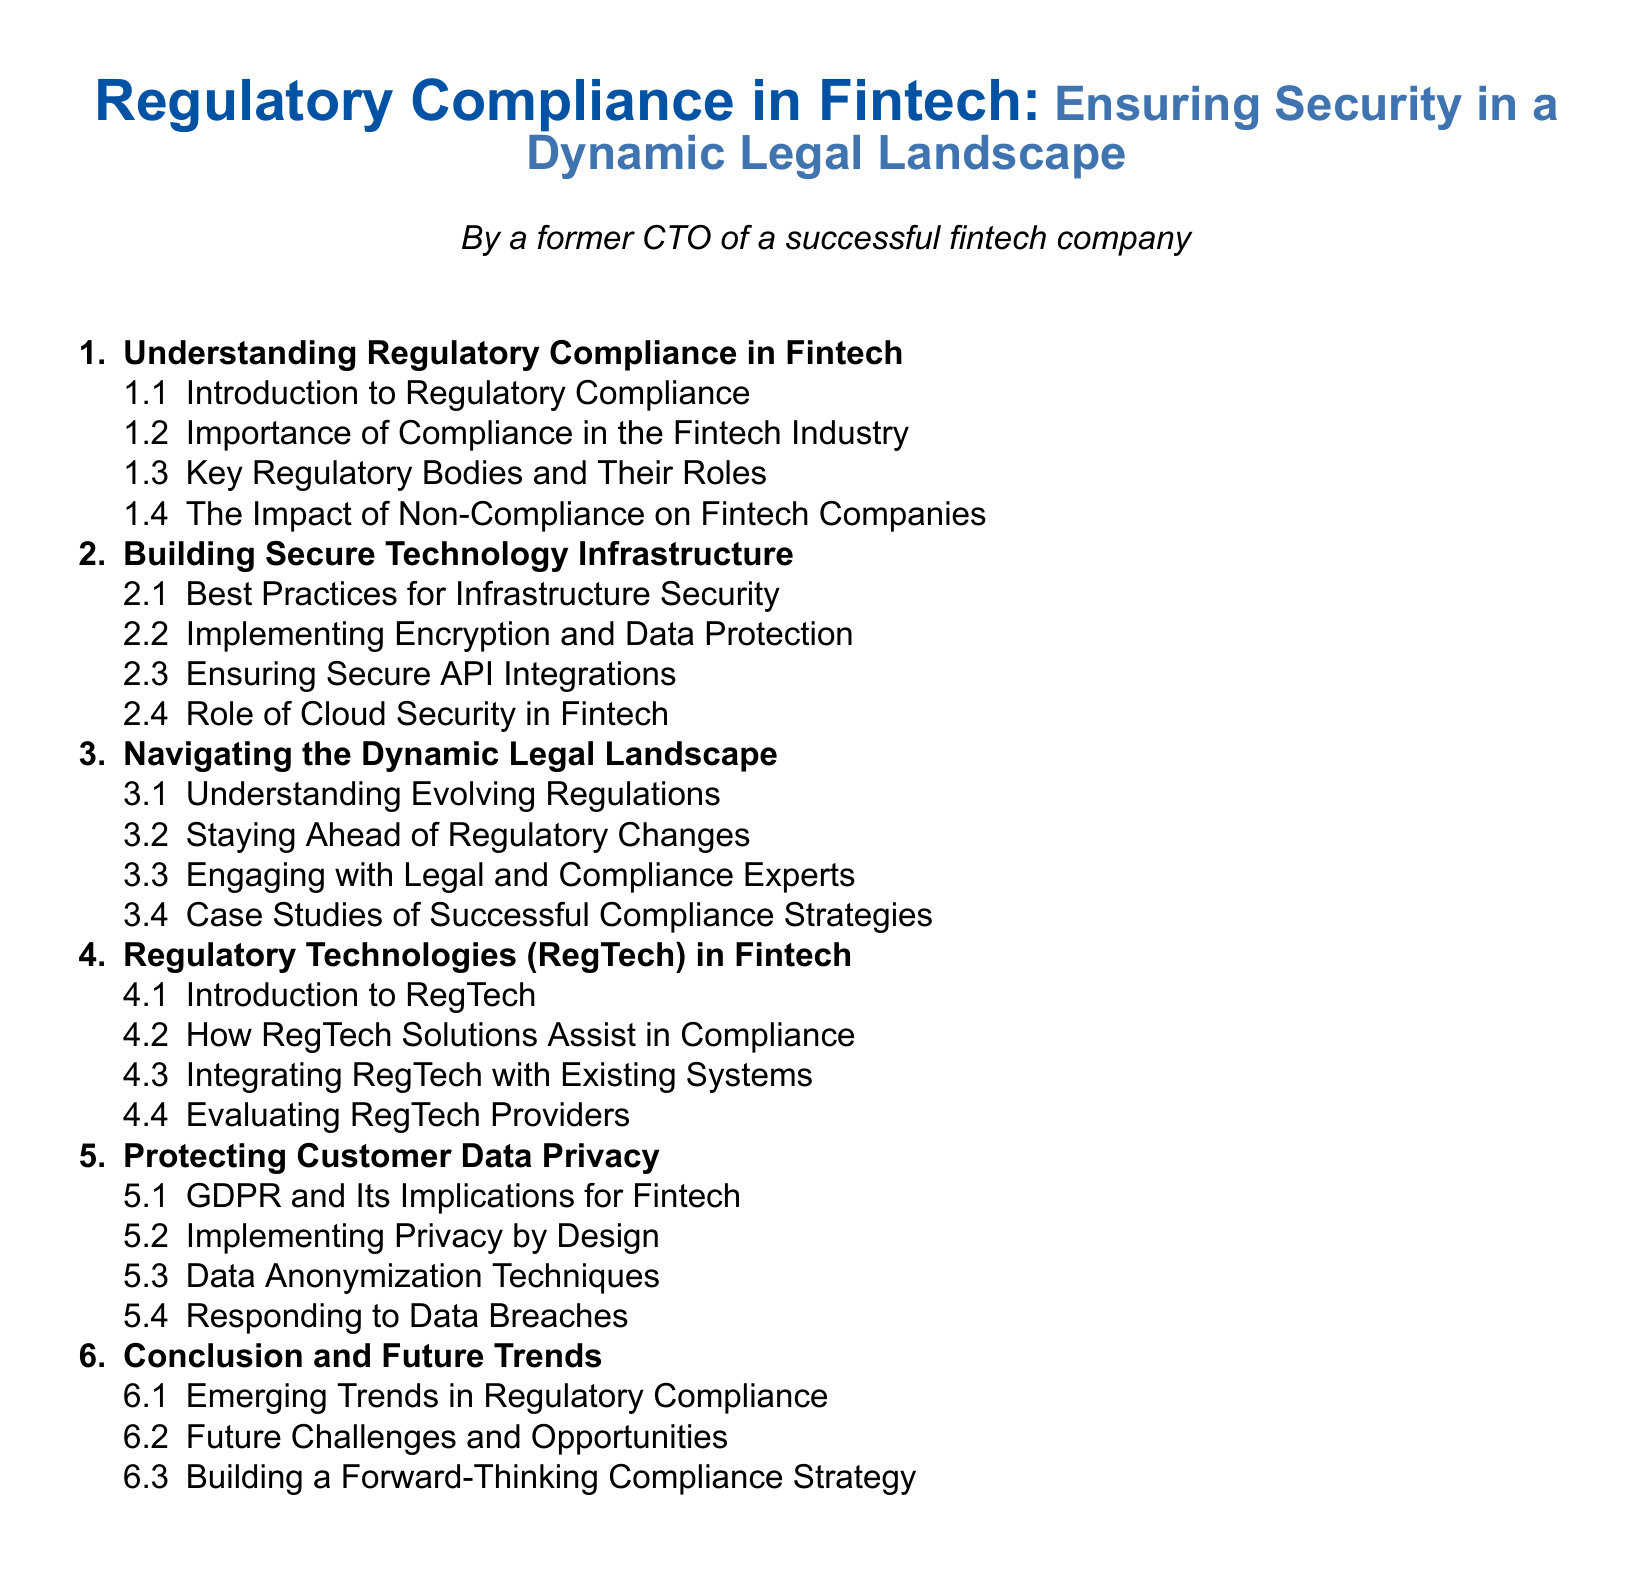What is the first section in the Table of Contents? The first section outlined in the Table of Contents is "Understanding Regulatory Compliance in Fintech."
Answer: Understanding Regulatory Compliance in Fintech How many subsections are in the first main section? The first main section has four subsections as listed.
Answer: 4 What is the topic of subsection 3.1? The topic of subsection 3.1 is "Understanding Evolving Regulations."
Answer: Understanding Evolving Regulations What is the last main section of the document? The last main section provided in the document structure is "Conclusion and Future Trends."
Answer: Conclusion and Future Trends How many total main sections are there in the Table of Contents? The document has a total of six main sections listed.
Answer: 6 What does subsection 5.2 focus on? Subsection 5.2 discusses "Implementing Privacy by Design."
Answer: Implementing Privacy by Design Which regulatory framework is mentioned in the document regarding customer data? The framework mentioned regarding customer data is the "GDPR."
Answer: GDPR What is the purpose of the second main section? The purpose of the second main section is to discuss "Building Secure Technology Infrastructure."
Answer: Building Secure Technology Infrastructure What term is introduced in the fourth main section? The term introduced in the fourth main section is "RegTech."
Answer: RegTech 